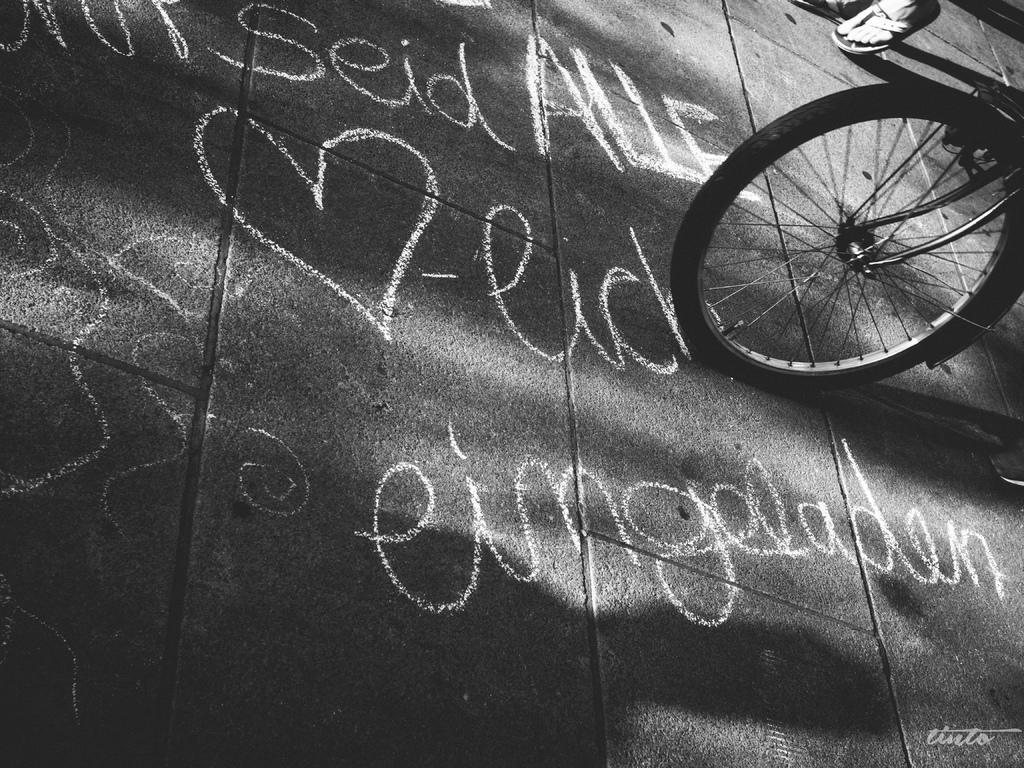Can you describe this image briefly? In this picture there is a person walking on the road. There is a person riding bicycle on the road. There is a text on the road. 